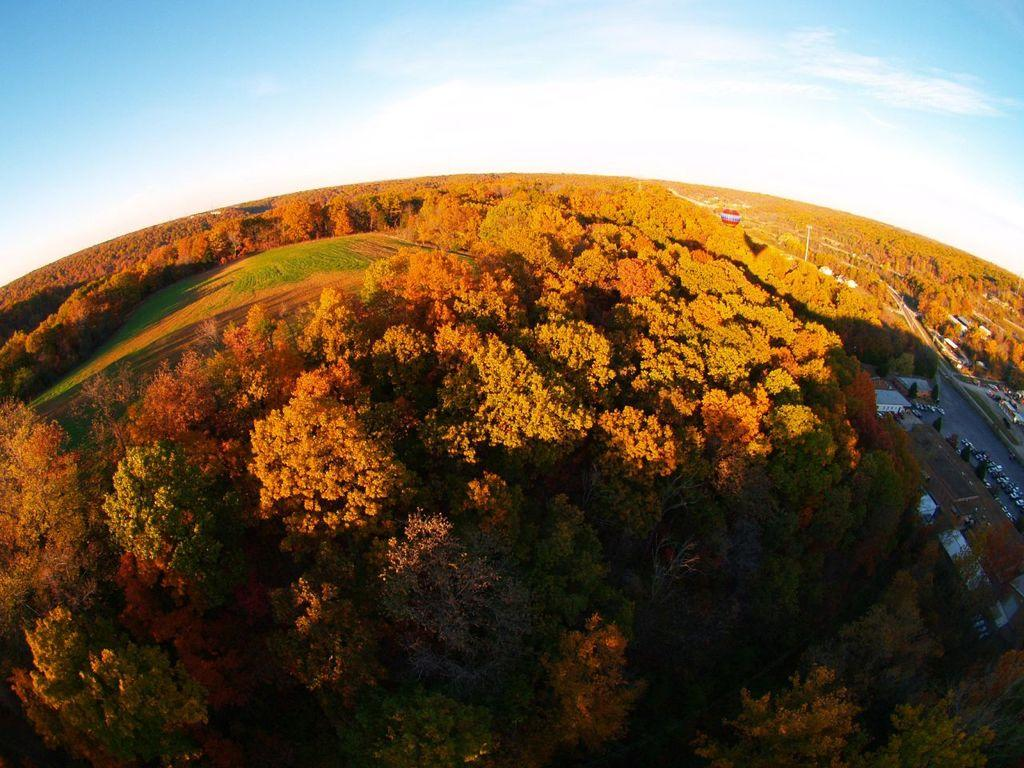What perspective is used in the image? The image shows a top view of a place. What type of structures can be seen in the image? There are houses in the image. What mode of transportation is visible in the image? There is a vehicle in the image. What object can be seen standing upright in the image? There is a pole in the image. What part of the natural environment is visible in the image? The sky is visible in the image. What type of vegetation is present in the image? Trees are present in the image. What surface can be seen at the bottom of the image? The ground is visible in the image. How many kittens are sitting on the vehicle in the image? There are no kittens present in the image; only a vehicle can be seen. What color is the tongue of the tree in the image? Trees do not have tongues, so this question cannot be answered. 